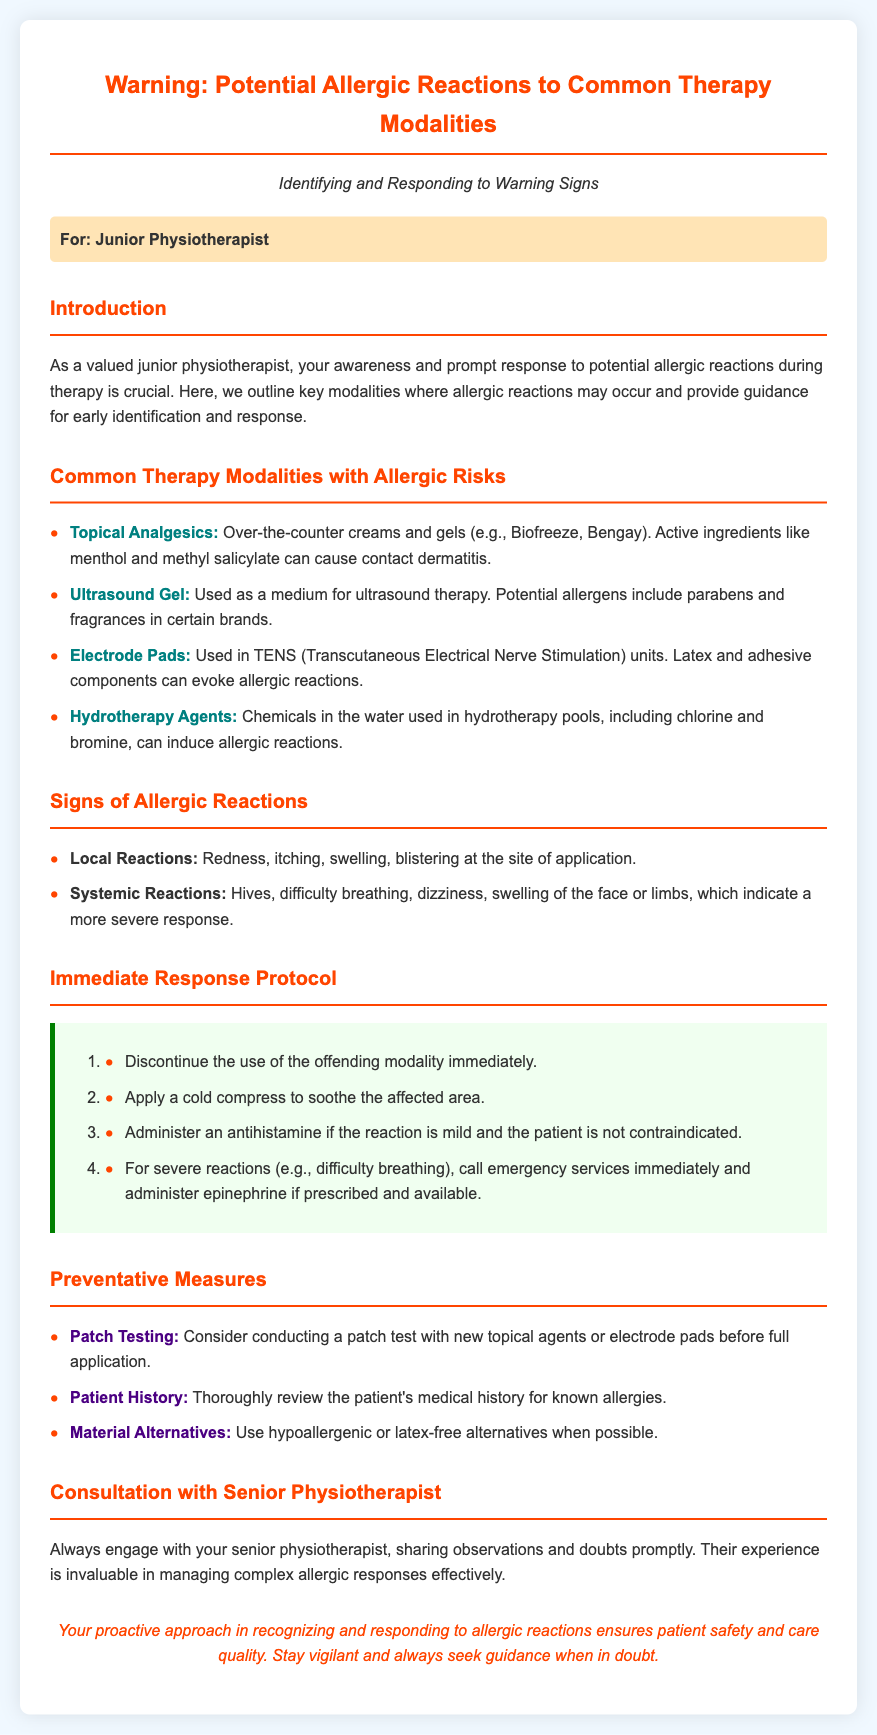What are the common therapy modalities with allergic risks? The section lists common therapy modalities such as topical analgesics, ultrasound gel, electrode pads, and hydrotherapy agents.
Answer: Topical Analgesics, Ultrasound Gel, Electrode Pads, Hydrotherapy Agents What is the first sign of a local allergic reaction? The document states that redness is a sign that can occur at the site of application.
Answer: Redness What should you do immediately if an allergic reaction occurs? The immediate response protocol starts with discontinuing the use of the offending modality.
Answer: Discontinue use What type of alternative materials should be considered? The document advises the use of hypoallergenic or latex-free alternatives.
Answer: Hypoallergenic or latex-free What is the role of the junior physiotherapist in this document? The document emphasizes the importance of the junior physiotherapist in recognizing and responding to allergic reactions.
Answer: Recognizing and responding What should you apply to soothe the affected area? The protocol mentions applying a cold compress to address the affected area after a reaction.
Answer: Cold compress 